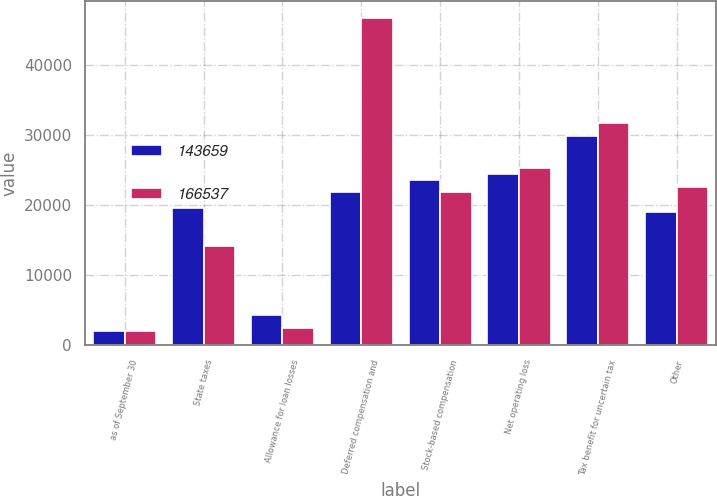Convert chart. <chart><loc_0><loc_0><loc_500><loc_500><stacked_bar_chart><ecel><fcel>as of September 30<fcel>State taxes<fcel>Allowance for loan losses<fcel>Deferred compensation and<fcel>Stock-based compensation<fcel>Net operating loss<fcel>Tax benefit for uncertain tax<fcel>Other<nl><fcel>143659<fcel>2011<fcel>19690<fcel>4343<fcel>21911<fcel>23601<fcel>24427<fcel>29925<fcel>19109<nl><fcel>166537<fcel>2010<fcel>14194<fcel>2423<fcel>46822<fcel>21911<fcel>25327<fcel>31735<fcel>22577<nl></chart> 